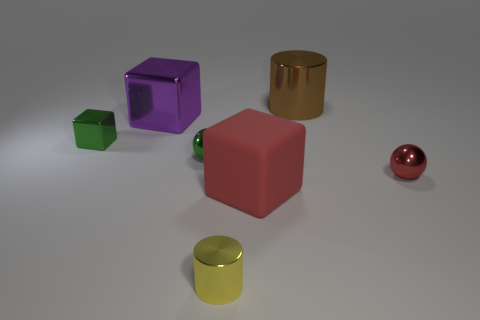What could be the purpose of these objects? These objects could serve as educational tools for children, teaching about shapes and colors, or they might be part of a visual composition, designed to explore geometric forms and color contrasts. 